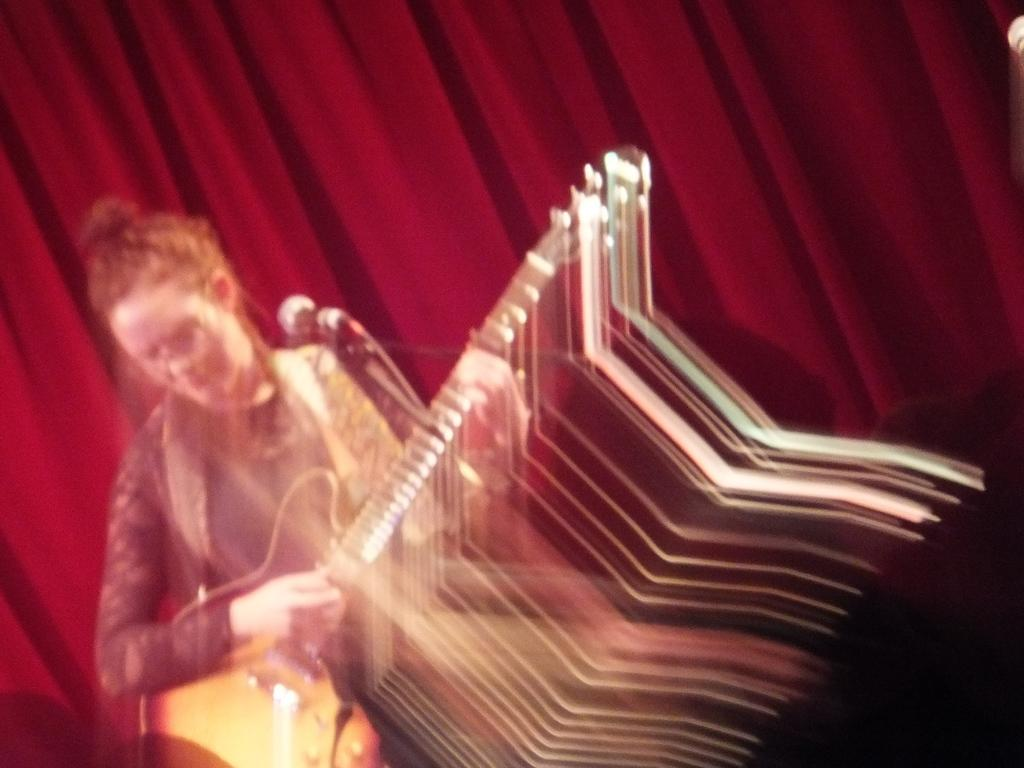Who is the main subject in the image? There is a lady in the image. What is the lady doing in the image? The lady is playing a guitar. Can you describe the quality of the image? The image of the lady playing guitar is blurred. What can be seen in the background of the image? There is a red curtain in the background of the image. How many horses can be seen in the image? There are no horses present in the image. What emotion does the lady express while playing the guitar? The image does not convey any specific emotion, and we cannot determine the lady's feelings from the image alone. 